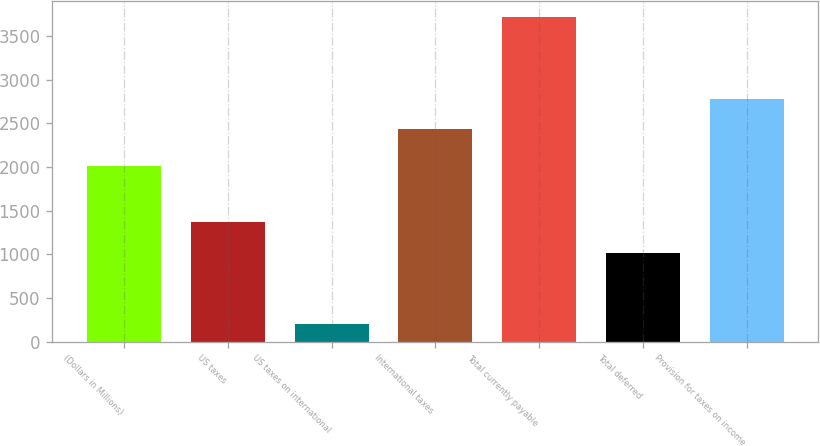Convert chart to OTSL. <chart><loc_0><loc_0><loc_500><loc_500><bar_chart><fcel>(Dollars in Millions)<fcel>US taxes<fcel>US taxes on international<fcel>International taxes<fcel>Total currently payable<fcel>Total deferred<fcel>Provision for taxes on income<nl><fcel>2018<fcel>1367.5<fcel>203<fcel>2434<fcel>3718<fcel>1016<fcel>2785.5<nl></chart> 